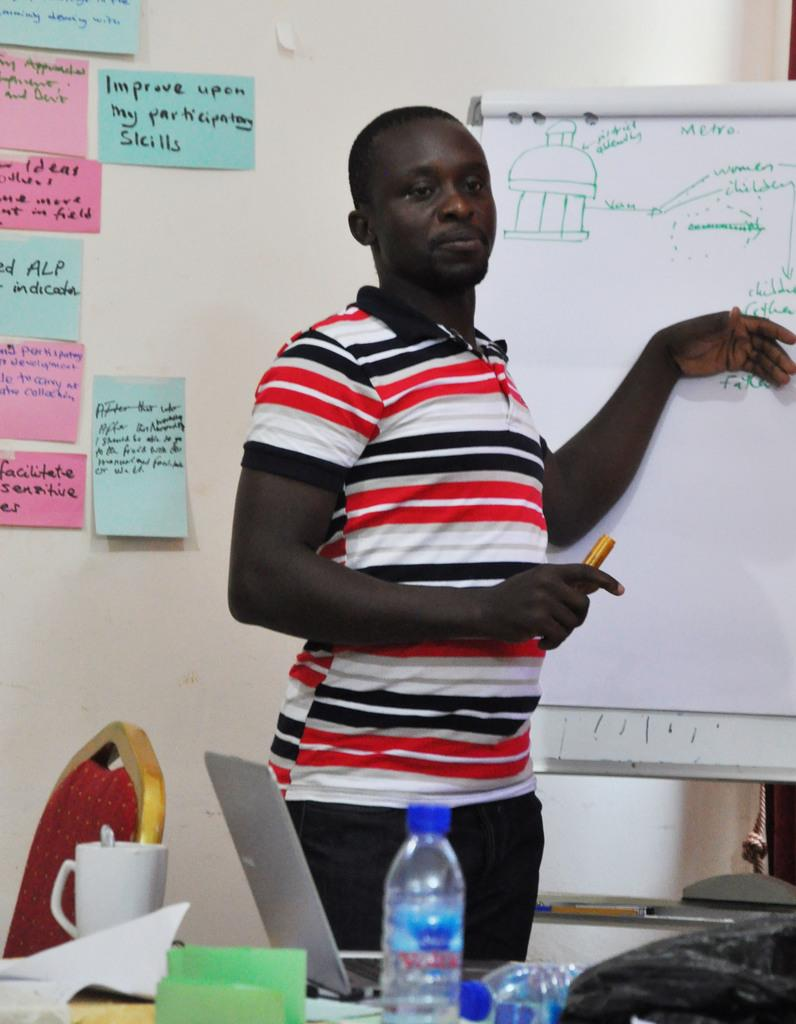<image>
Give a short and clear explanation of the subsequent image. Man at white board that has a drawing and Metra in green. 